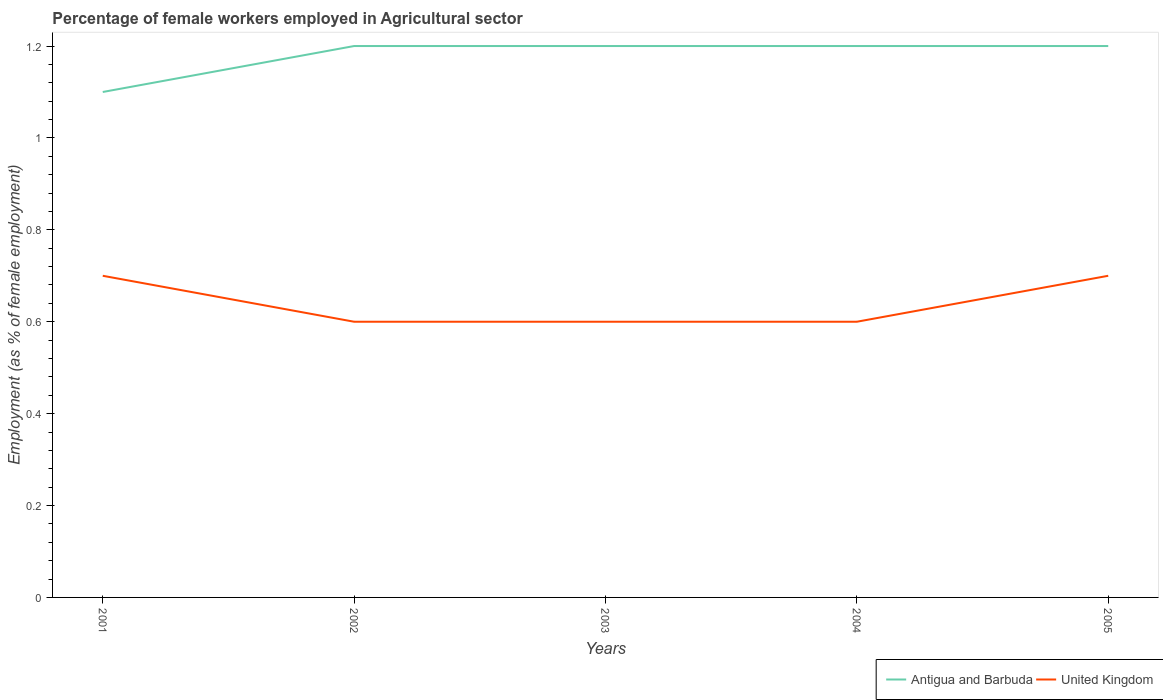Across all years, what is the maximum percentage of females employed in Agricultural sector in Antigua and Barbuda?
Your answer should be very brief. 1.1. What is the total percentage of females employed in Agricultural sector in Antigua and Barbuda in the graph?
Your answer should be very brief. 0. What is the difference between the highest and the second highest percentage of females employed in Agricultural sector in Antigua and Barbuda?
Provide a succinct answer. 0.1. How many lines are there?
Offer a very short reply. 2. What is the title of the graph?
Your answer should be very brief. Percentage of female workers employed in Agricultural sector. What is the label or title of the X-axis?
Ensure brevity in your answer.  Years. What is the label or title of the Y-axis?
Make the answer very short. Employment (as % of female employment). What is the Employment (as % of female employment) in Antigua and Barbuda in 2001?
Provide a short and direct response. 1.1. What is the Employment (as % of female employment) in United Kingdom in 2001?
Give a very brief answer. 0.7. What is the Employment (as % of female employment) in Antigua and Barbuda in 2002?
Give a very brief answer. 1.2. What is the Employment (as % of female employment) in United Kingdom in 2002?
Make the answer very short. 0.6. What is the Employment (as % of female employment) in Antigua and Barbuda in 2003?
Offer a very short reply. 1.2. What is the Employment (as % of female employment) in United Kingdom in 2003?
Offer a very short reply. 0.6. What is the Employment (as % of female employment) in Antigua and Barbuda in 2004?
Make the answer very short. 1.2. What is the Employment (as % of female employment) of United Kingdom in 2004?
Your response must be concise. 0.6. What is the Employment (as % of female employment) of Antigua and Barbuda in 2005?
Provide a short and direct response. 1.2. What is the Employment (as % of female employment) in United Kingdom in 2005?
Your answer should be compact. 0.7. Across all years, what is the maximum Employment (as % of female employment) of Antigua and Barbuda?
Make the answer very short. 1.2. Across all years, what is the maximum Employment (as % of female employment) of United Kingdom?
Ensure brevity in your answer.  0.7. Across all years, what is the minimum Employment (as % of female employment) of Antigua and Barbuda?
Offer a terse response. 1.1. Across all years, what is the minimum Employment (as % of female employment) in United Kingdom?
Make the answer very short. 0.6. What is the total Employment (as % of female employment) of Antigua and Barbuda in the graph?
Your response must be concise. 5.9. What is the total Employment (as % of female employment) of United Kingdom in the graph?
Provide a short and direct response. 3.2. What is the difference between the Employment (as % of female employment) in United Kingdom in 2001 and that in 2002?
Offer a terse response. 0.1. What is the difference between the Employment (as % of female employment) in Antigua and Barbuda in 2001 and that in 2003?
Your response must be concise. -0.1. What is the difference between the Employment (as % of female employment) of Antigua and Barbuda in 2001 and that in 2004?
Provide a succinct answer. -0.1. What is the difference between the Employment (as % of female employment) in United Kingdom in 2001 and that in 2004?
Give a very brief answer. 0.1. What is the difference between the Employment (as % of female employment) in Antigua and Barbuda in 2001 and that in 2005?
Provide a short and direct response. -0.1. What is the difference between the Employment (as % of female employment) of Antigua and Barbuda in 2002 and that in 2003?
Provide a short and direct response. 0. What is the difference between the Employment (as % of female employment) in United Kingdom in 2002 and that in 2003?
Provide a succinct answer. 0. What is the difference between the Employment (as % of female employment) of United Kingdom in 2002 and that in 2004?
Ensure brevity in your answer.  0. What is the difference between the Employment (as % of female employment) in United Kingdom in 2003 and that in 2005?
Keep it short and to the point. -0.1. What is the difference between the Employment (as % of female employment) in Antigua and Barbuda in 2004 and that in 2005?
Your answer should be very brief. 0. What is the difference between the Employment (as % of female employment) in Antigua and Barbuda in 2001 and the Employment (as % of female employment) in United Kingdom in 2002?
Keep it short and to the point. 0.5. What is the difference between the Employment (as % of female employment) in Antigua and Barbuda in 2001 and the Employment (as % of female employment) in United Kingdom in 2004?
Offer a very short reply. 0.5. What is the difference between the Employment (as % of female employment) in Antigua and Barbuda in 2001 and the Employment (as % of female employment) in United Kingdom in 2005?
Offer a terse response. 0.4. What is the difference between the Employment (as % of female employment) in Antigua and Barbuda in 2003 and the Employment (as % of female employment) in United Kingdom in 2005?
Provide a short and direct response. 0.5. What is the difference between the Employment (as % of female employment) of Antigua and Barbuda in 2004 and the Employment (as % of female employment) of United Kingdom in 2005?
Your answer should be very brief. 0.5. What is the average Employment (as % of female employment) of Antigua and Barbuda per year?
Keep it short and to the point. 1.18. What is the average Employment (as % of female employment) of United Kingdom per year?
Offer a terse response. 0.64. In the year 2002, what is the difference between the Employment (as % of female employment) in Antigua and Barbuda and Employment (as % of female employment) in United Kingdom?
Ensure brevity in your answer.  0.6. In the year 2003, what is the difference between the Employment (as % of female employment) in Antigua and Barbuda and Employment (as % of female employment) in United Kingdom?
Offer a very short reply. 0.6. In the year 2004, what is the difference between the Employment (as % of female employment) in Antigua and Barbuda and Employment (as % of female employment) in United Kingdom?
Offer a terse response. 0.6. In the year 2005, what is the difference between the Employment (as % of female employment) in Antigua and Barbuda and Employment (as % of female employment) in United Kingdom?
Give a very brief answer. 0.5. What is the ratio of the Employment (as % of female employment) of Antigua and Barbuda in 2001 to that in 2002?
Keep it short and to the point. 0.92. What is the ratio of the Employment (as % of female employment) in United Kingdom in 2001 to that in 2002?
Offer a terse response. 1.17. What is the ratio of the Employment (as % of female employment) in Antigua and Barbuda in 2001 to that in 2003?
Offer a terse response. 0.92. What is the ratio of the Employment (as % of female employment) of United Kingdom in 2001 to that in 2003?
Keep it short and to the point. 1.17. What is the ratio of the Employment (as % of female employment) of United Kingdom in 2001 to that in 2004?
Make the answer very short. 1.17. What is the ratio of the Employment (as % of female employment) in Antigua and Barbuda in 2002 to that in 2004?
Offer a very short reply. 1. What is the ratio of the Employment (as % of female employment) in United Kingdom in 2003 to that in 2005?
Keep it short and to the point. 0.86. What is the difference between the highest and the lowest Employment (as % of female employment) of United Kingdom?
Your answer should be compact. 0.1. 